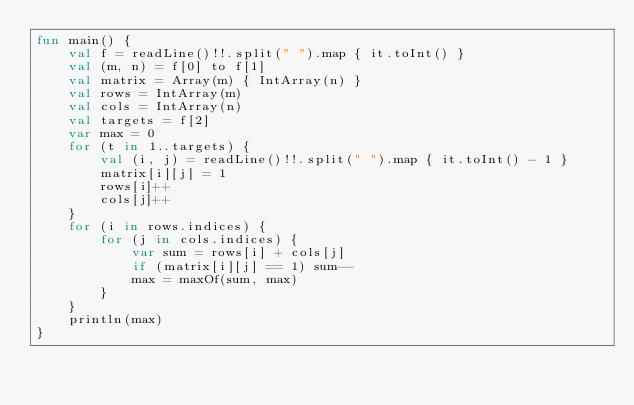<code> <loc_0><loc_0><loc_500><loc_500><_Kotlin_>fun main() {
    val f = readLine()!!.split(" ").map { it.toInt() }
    val (m, n) = f[0] to f[1]
    val matrix = Array(m) { IntArray(n) }
    val rows = IntArray(m)
    val cols = IntArray(n)
    val targets = f[2]
    var max = 0
    for (t in 1..targets) {
        val (i, j) = readLine()!!.split(" ").map { it.toInt() - 1 }
        matrix[i][j] = 1
        rows[i]++
        cols[j]++
    }
    for (i in rows.indices) {
        for (j in cols.indices) {
            var sum = rows[i] + cols[j]
            if (matrix[i][j] == 1) sum--
            max = maxOf(sum, max)
        }
    }
    println(max)
}</code> 